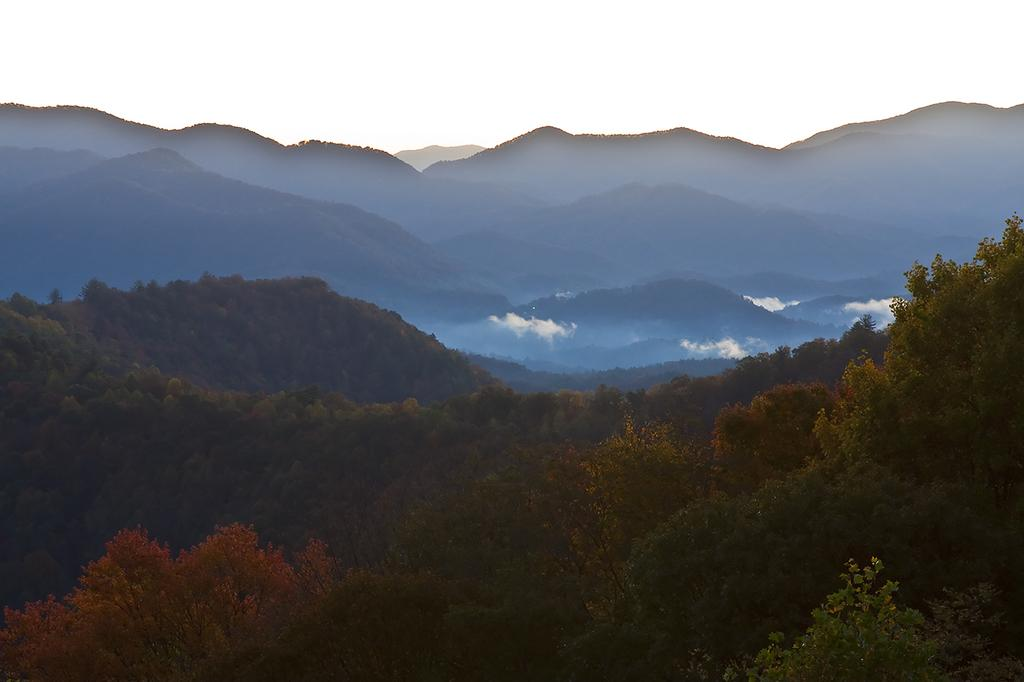What type of vegetation can be seen in the image? There are trees in the image. What geographical feature is present in the image? There is a mountain in the image. What part of the natural environment is visible in the image? The sky is visible in the image. What type of iron can be seen in the image? There is no iron present in the image. What need is being fulfilled by the trees in the image? The trees in the image are not fulfilling a specific need; they are simply part of the natural landscape. 